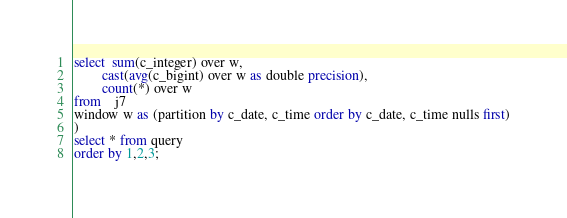<code> <loc_0><loc_0><loc_500><loc_500><_SQL_>select  sum(c_integer) over w,
        cast(avg(c_bigint) over w as double precision),
        count(*) over w
from    j7
window w as (partition by c_date, c_time order by c_date, c_time nulls first)
)
select * from query
order by 1,2,3;
</code> 